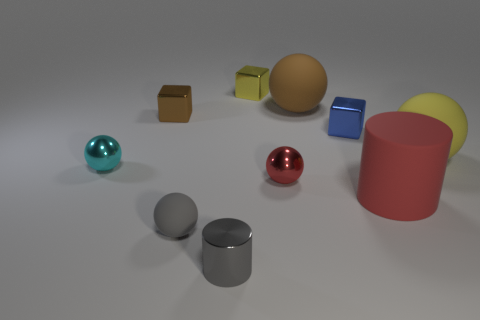Is there any other thing that has the same material as the tiny yellow object?
Give a very brief answer. Yes. How many red rubber things are there?
Your answer should be compact. 1. Does the small metal cylinder have the same color as the big rubber cylinder?
Offer a very short reply. No. There is a small thing that is both to the left of the small gray shiny thing and right of the brown metal cube; what is its color?
Give a very brief answer. Gray. Are there any small gray metallic cylinders in front of the cyan shiny object?
Make the answer very short. Yes. There is a object that is on the left side of the tiny brown metal block; how many rubber objects are right of it?
Offer a terse response. 4. There is a gray cylinder that is made of the same material as the yellow cube; what is its size?
Offer a very short reply. Small. What size is the red metallic thing?
Provide a short and direct response. Small. Does the tiny brown cube have the same material as the red sphere?
Give a very brief answer. Yes. What number of cylinders are big yellow things or tiny gray matte things?
Provide a short and direct response. 0. 